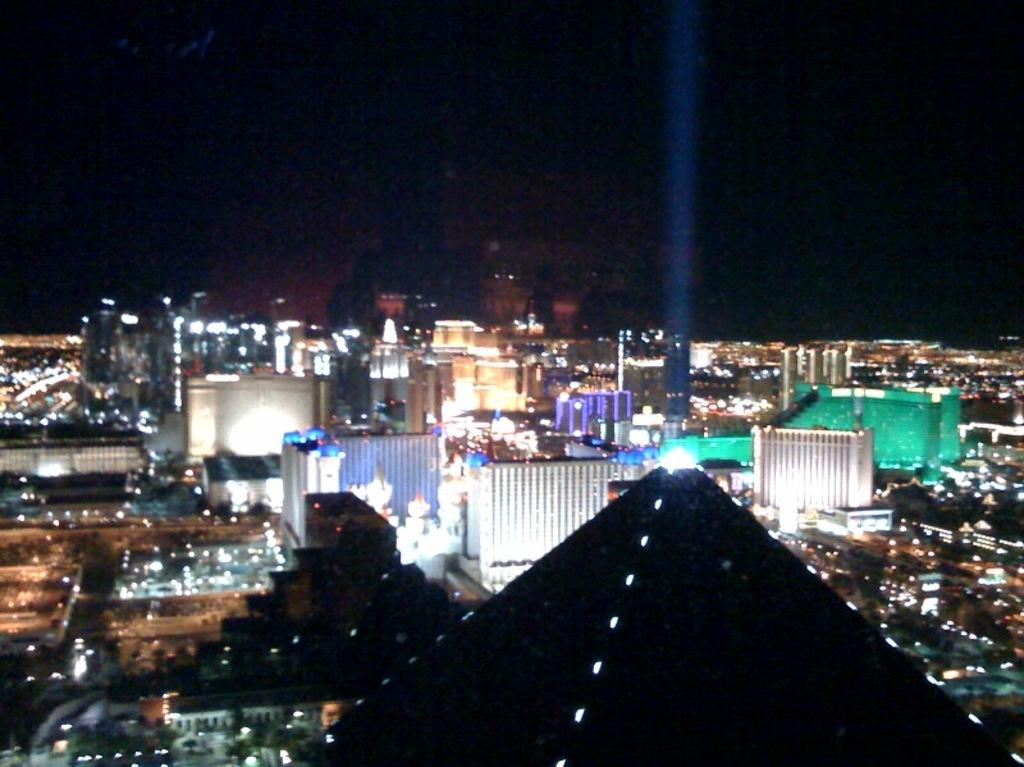What type of structures can be seen in the image? There are buildings in the image. What can be seen illuminating the buildings in the image? There are lights visible in the image. What can be inferred about the time of day or lighting conditions when the image was taken? The image appears to be taken in the dark. What type of sport is being played in the image? There is no sport or volleyball visible in the image. What type of utensil is being used in the image? There is no utensil or spoon present in the image. What type of symbol or emblem can be seen in the image? There is no symbol or flag present in the image. 